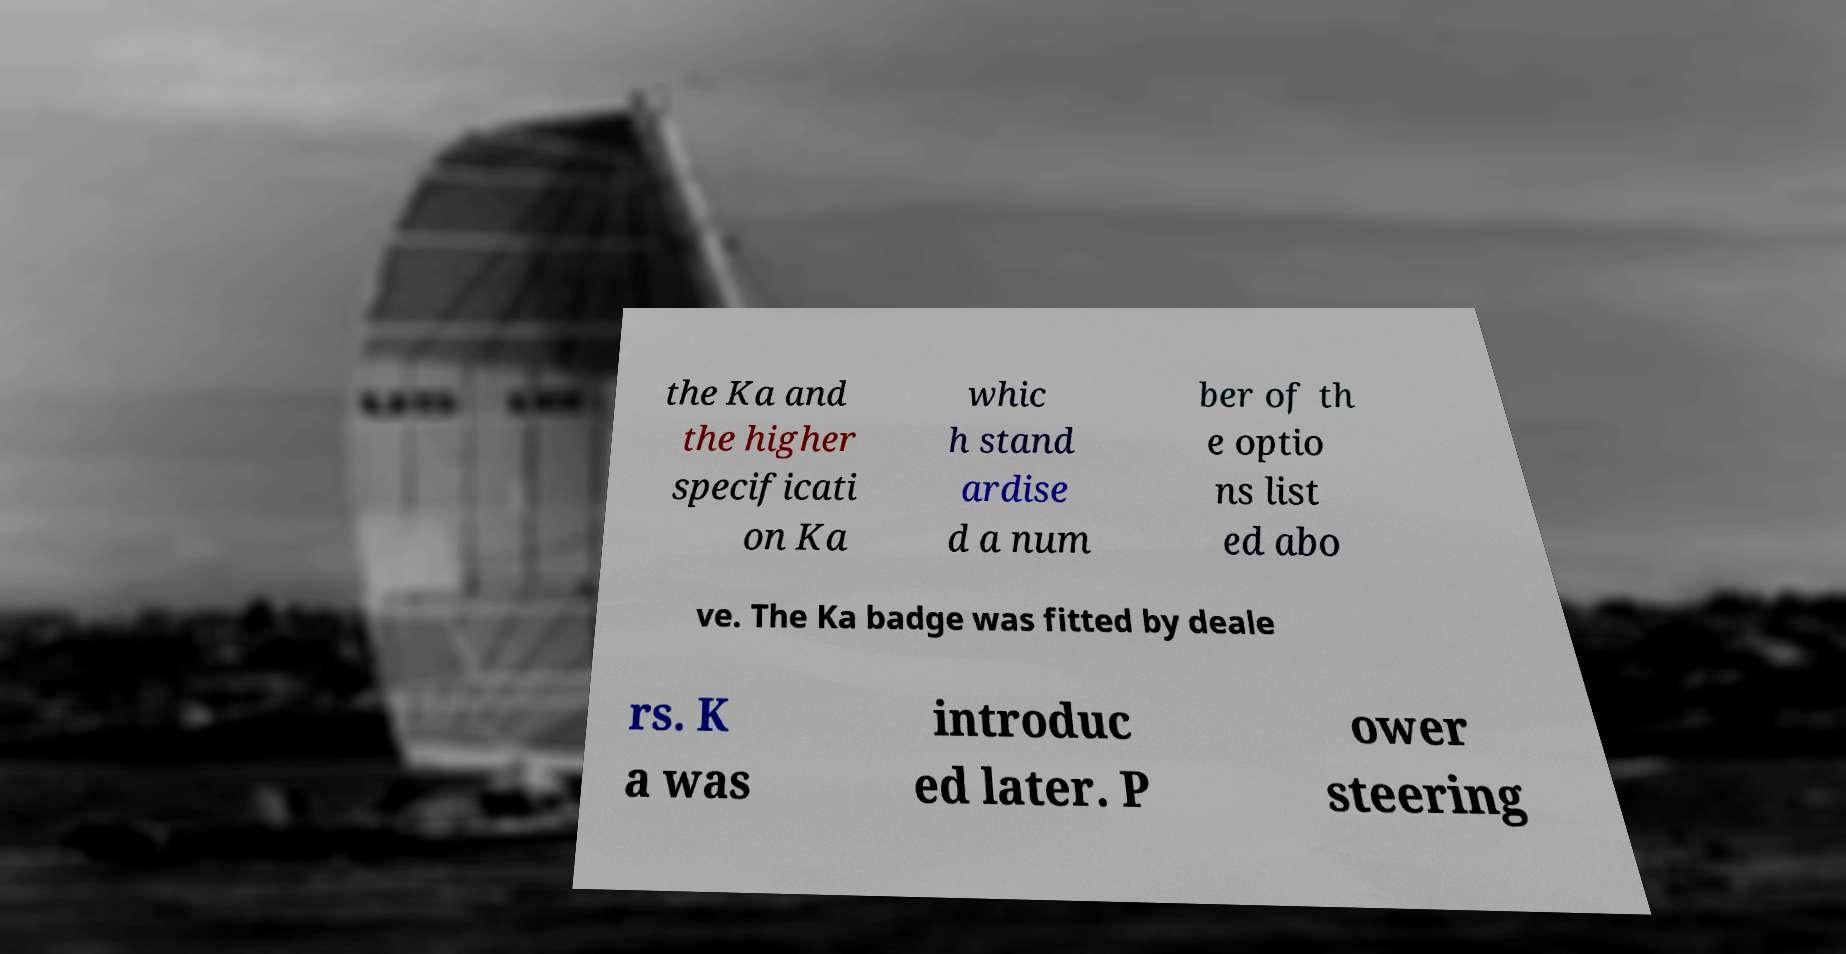What messages or text are displayed in this image? I need them in a readable, typed format. the Ka and the higher specificati on Ka whic h stand ardise d a num ber of th e optio ns list ed abo ve. The Ka badge was fitted by deale rs. K a was introduc ed later. P ower steering 